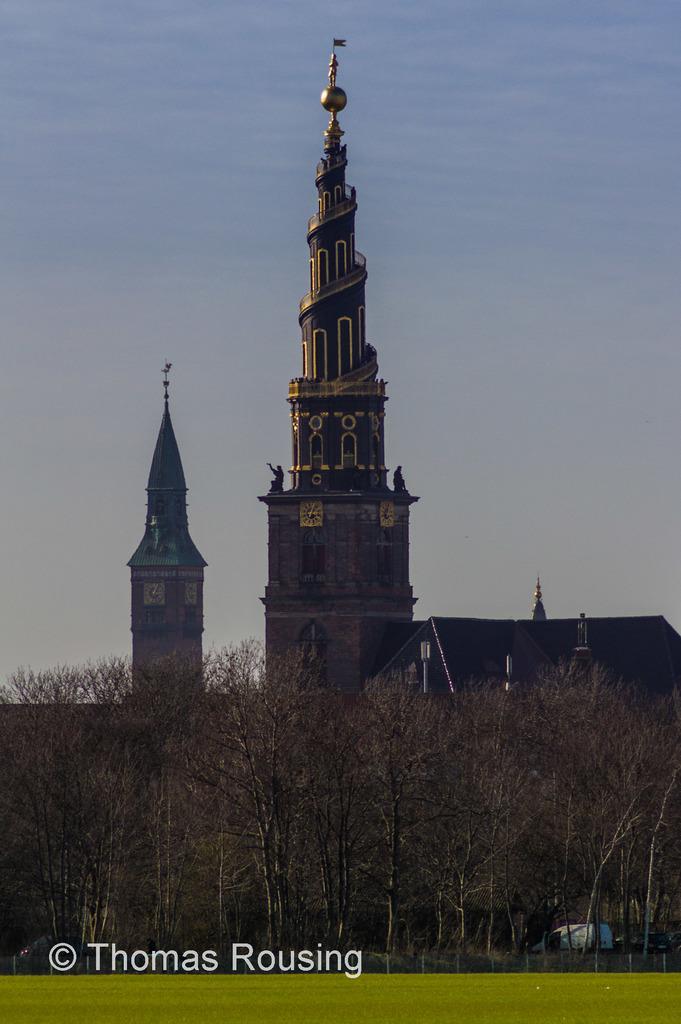In one or two sentences, can you explain what this image depicts? In this picture we can see buildings with windows, trees, grass, fence and in the background we can see the sky with clouds. 